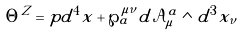<formula> <loc_0><loc_0><loc_500><loc_500>\Theta ^ { Z } = p d ^ { 4 } x + \wp _ { a } ^ { \mu \nu } d \mathcal { A } _ { \mu } ^ { a } \wedge d ^ { 3 } x _ { \nu }</formula> 